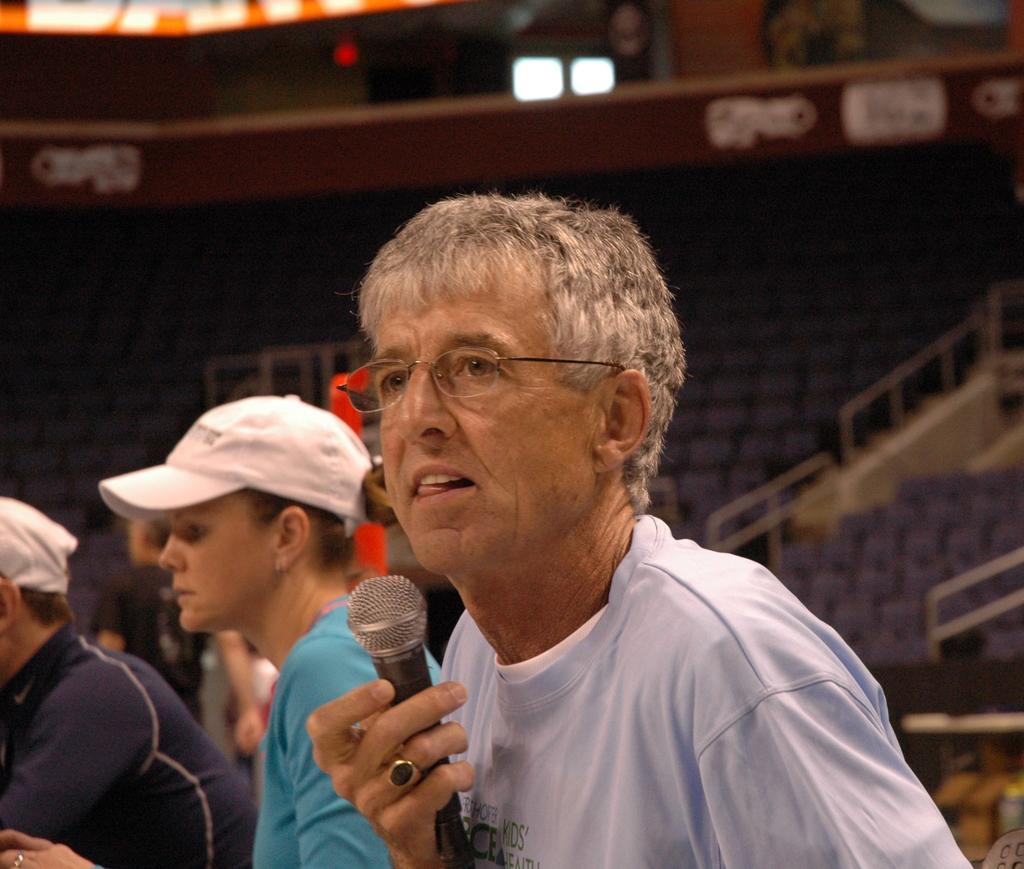Can you describe this image briefly? In this picture we can see a man who is holding a mike his hand. He has spectacles. Here we can see some persons. She wear a cap. On the background we can see some chairs. And this is light. 